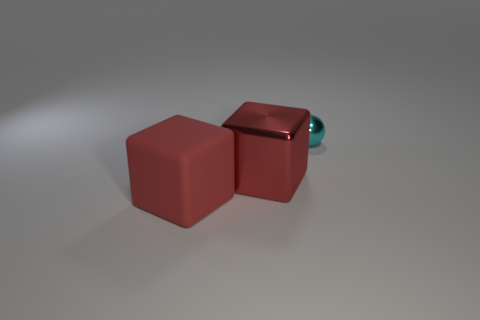If these objects were part of a game, how might they be used? In the context of a game, the cubes might serve as building blocks or obstacles, while the smaller sphere could be a playing piece that players move around, perhaps navigating the space between or atop the cubes. 